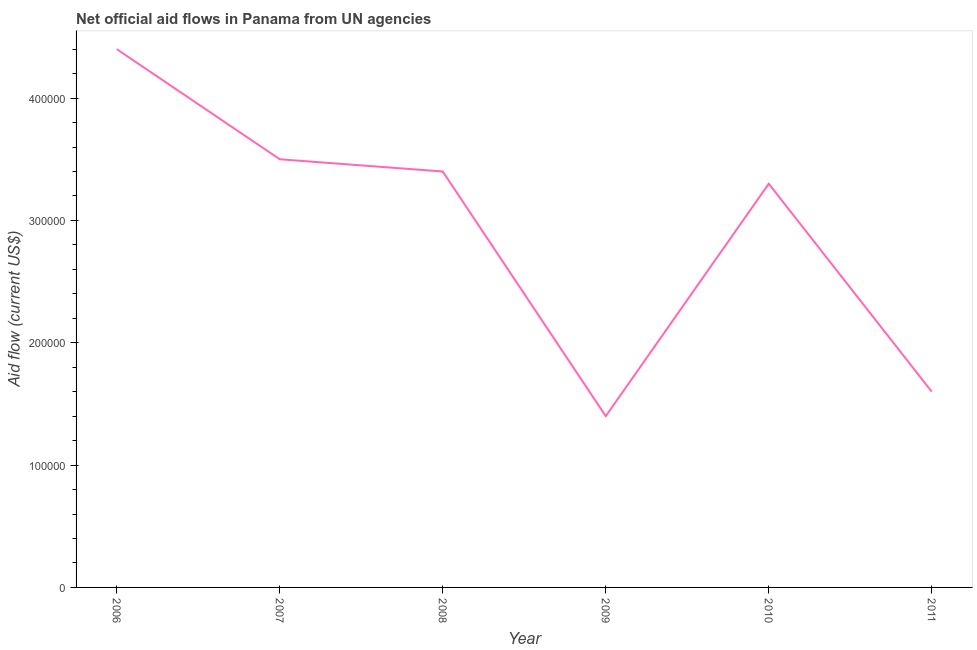What is the net official flows from un agencies in 2010?
Keep it short and to the point. 3.30e+05. Across all years, what is the maximum net official flows from un agencies?
Your answer should be very brief. 4.40e+05. Across all years, what is the minimum net official flows from un agencies?
Your answer should be compact. 1.40e+05. In which year was the net official flows from un agencies maximum?
Offer a terse response. 2006. In which year was the net official flows from un agencies minimum?
Your answer should be compact. 2009. What is the sum of the net official flows from un agencies?
Offer a very short reply. 1.76e+06. What is the difference between the net official flows from un agencies in 2006 and 2011?
Offer a terse response. 2.80e+05. What is the average net official flows from un agencies per year?
Make the answer very short. 2.93e+05. What is the median net official flows from un agencies?
Offer a very short reply. 3.35e+05. In how many years, is the net official flows from un agencies greater than 420000 US$?
Provide a succinct answer. 1. What is the ratio of the net official flows from un agencies in 2007 to that in 2011?
Keep it short and to the point. 2.19. Is the net official flows from un agencies in 2008 less than that in 2011?
Your answer should be very brief. No. Is the difference between the net official flows from un agencies in 2009 and 2010 greater than the difference between any two years?
Offer a terse response. No. Is the sum of the net official flows from un agencies in 2007 and 2008 greater than the maximum net official flows from un agencies across all years?
Make the answer very short. Yes. What is the difference between the highest and the lowest net official flows from un agencies?
Your answer should be compact. 3.00e+05. Does the net official flows from un agencies monotonically increase over the years?
Offer a very short reply. No. How many years are there in the graph?
Ensure brevity in your answer.  6. What is the difference between two consecutive major ticks on the Y-axis?
Your answer should be compact. 1.00e+05. Does the graph contain grids?
Provide a short and direct response. No. What is the title of the graph?
Provide a succinct answer. Net official aid flows in Panama from UN agencies. What is the Aid flow (current US$) in 2007?
Provide a succinct answer. 3.50e+05. What is the Aid flow (current US$) of 2008?
Ensure brevity in your answer.  3.40e+05. What is the Aid flow (current US$) of 2009?
Ensure brevity in your answer.  1.40e+05. What is the difference between the Aid flow (current US$) in 2006 and 2008?
Make the answer very short. 1.00e+05. What is the difference between the Aid flow (current US$) in 2007 and 2009?
Your response must be concise. 2.10e+05. What is the difference between the Aid flow (current US$) in 2007 and 2010?
Make the answer very short. 2.00e+04. What is the difference between the Aid flow (current US$) in 2008 and 2011?
Give a very brief answer. 1.80e+05. What is the difference between the Aid flow (current US$) in 2009 and 2010?
Give a very brief answer. -1.90e+05. What is the ratio of the Aid flow (current US$) in 2006 to that in 2007?
Keep it short and to the point. 1.26. What is the ratio of the Aid flow (current US$) in 2006 to that in 2008?
Offer a terse response. 1.29. What is the ratio of the Aid flow (current US$) in 2006 to that in 2009?
Make the answer very short. 3.14. What is the ratio of the Aid flow (current US$) in 2006 to that in 2010?
Make the answer very short. 1.33. What is the ratio of the Aid flow (current US$) in 2006 to that in 2011?
Offer a terse response. 2.75. What is the ratio of the Aid flow (current US$) in 2007 to that in 2009?
Your answer should be very brief. 2.5. What is the ratio of the Aid flow (current US$) in 2007 to that in 2010?
Provide a short and direct response. 1.06. What is the ratio of the Aid flow (current US$) in 2007 to that in 2011?
Your response must be concise. 2.19. What is the ratio of the Aid flow (current US$) in 2008 to that in 2009?
Offer a terse response. 2.43. What is the ratio of the Aid flow (current US$) in 2008 to that in 2011?
Make the answer very short. 2.12. What is the ratio of the Aid flow (current US$) in 2009 to that in 2010?
Ensure brevity in your answer.  0.42. What is the ratio of the Aid flow (current US$) in 2010 to that in 2011?
Your answer should be compact. 2.06. 